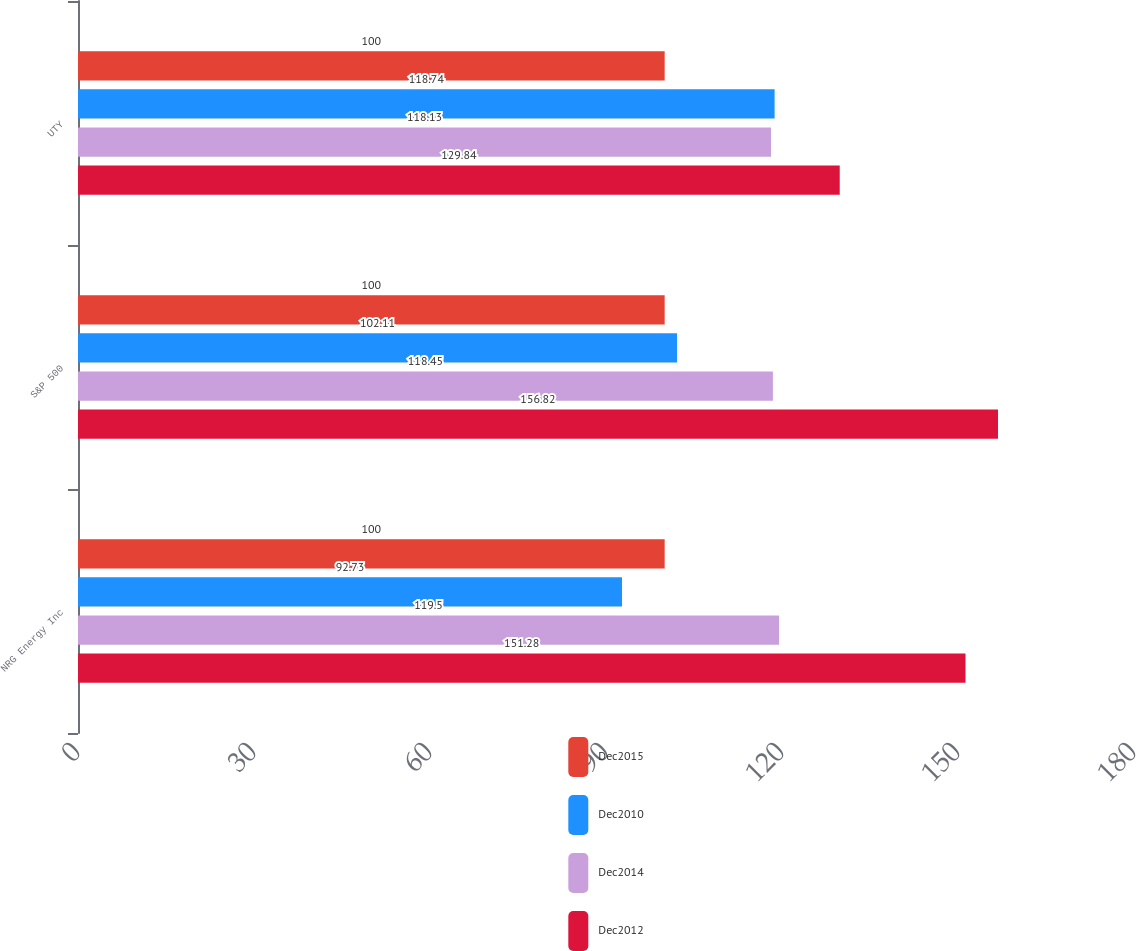Convert chart to OTSL. <chart><loc_0><loc_0><loc_500><loc_500><stacked_bar_chart><ecel><fcel>NRG Energy Inc<fcel>S&P 500<fcel>UTY<nl><fcel>Dec2015<fcel>100<fcel>100<fcel>100<nl><fcel>Dec2010<fcel>92.73<fcel>102.11<fcel>118.74<nl><fcel>Dec2014<fcel>119.5<fcel>118.45<fcel>118.13<nl><fcel>Dec2012<fcel>151.28<fcel>156.82<fcel>129.84<nl></chart> 